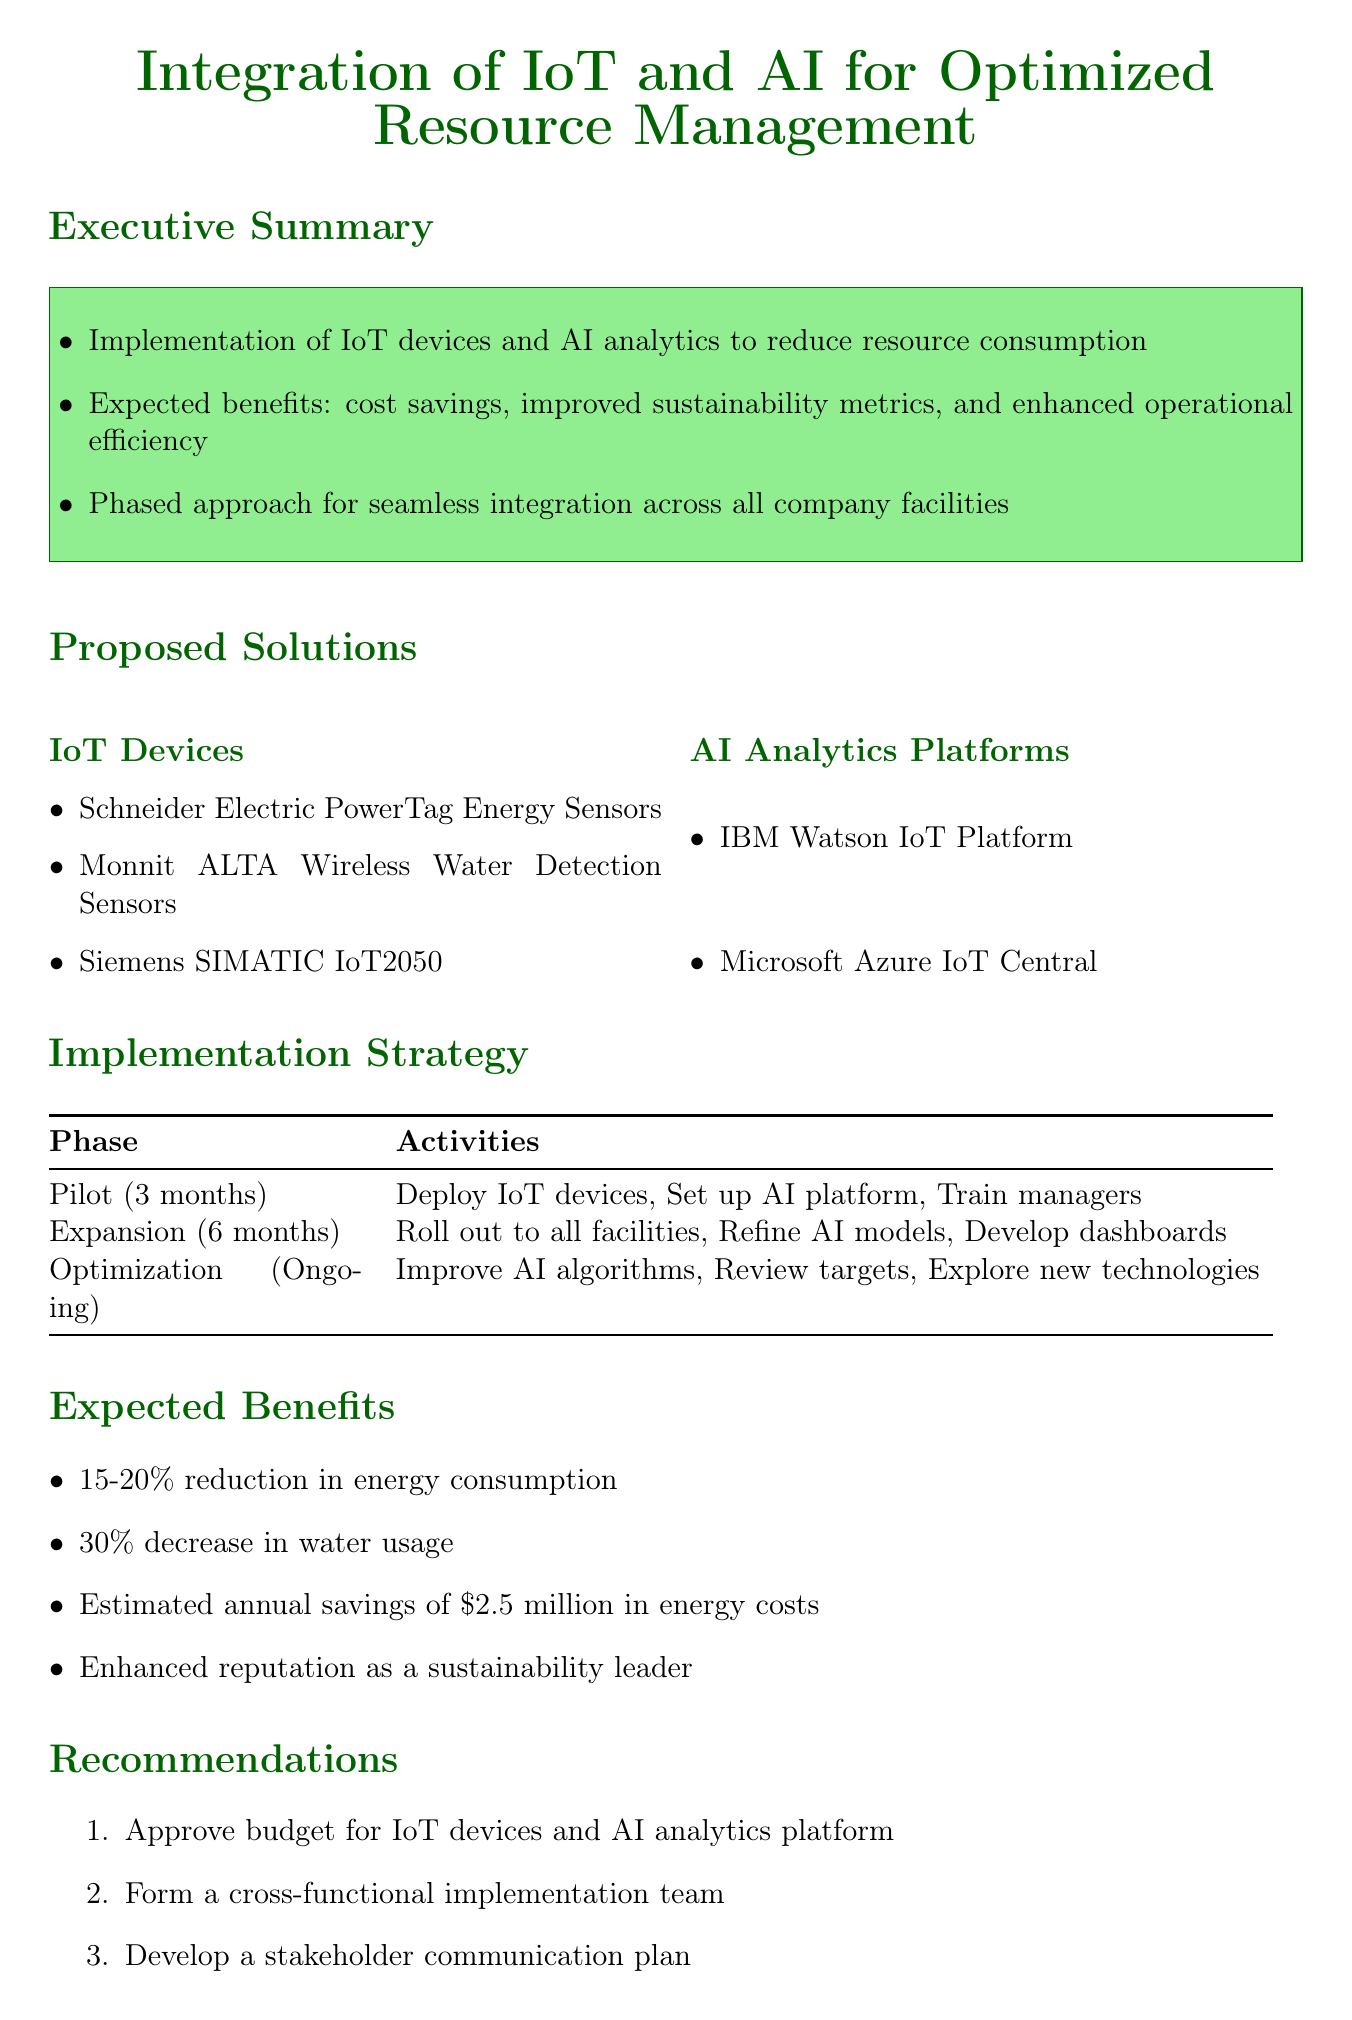What is the expected reduction in energy consumption? The document states a 15-20% reduction in energy consumption across all facilities.
Answer: 15-20% What is one of the sustainability goals mentioned? The document lists several sustainability goals, including reducing overall energy consumption by 30% within 3 years.
Answer: Reduce overall energy consumption by 30% Which AI analytics platform is suggested for integration? The document mentions IBM Watson IoT Platform and Microsoft Azure IoT Central as proposed solutions.
Answer: IBM Watson IoT Platform What is the duration of the Pilot Phase? The implementation strategy specifies that the Pilot Phase lasts for 3 months.
Answer: 3 months What is the estimated annual savings mentioned? The document states an estimated annual savings of $2.5 million in energy costs.
Answer: $2.5 million What type of devices will be used for leak detection? The memo proposes Monnit ALTA Wireless Water Detection Sensors for this purpose.
Answer: Monnit ALTA Wireless Water Detection Sensors What is one recommendation made in the memo? The memo includes several recommendations, one of which is to approve the budget for IoT devices and AI analytics platform.
Answer: Approve budget for IoT devices and AI analytics platform What is a key benefit of using AI-driven analytics? One of the expected benefits listed in the document is reduced maintenance expenses through predictive maintenance.
Answer: Reduced maintenance expenses through predictive maintenance What is the primary focus of the integration initiative? The core purpose of this initiative is to optimize resource consumption across all company facilities.
Answer: Optimize resource consumption across all company facilities 